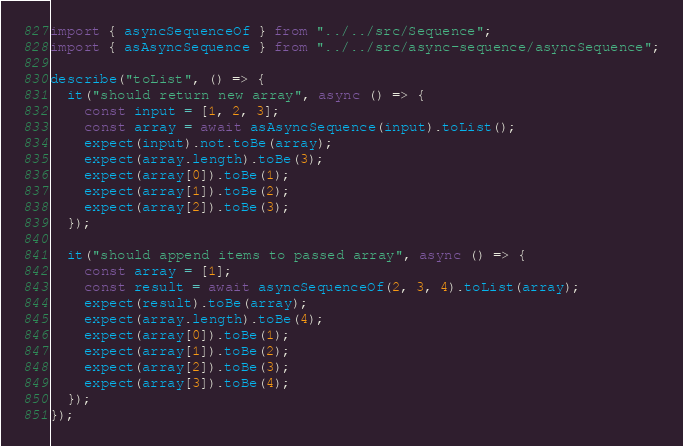<code> <loc_0><loc_0><loc_500><loc_500><_TypeScript_>import { asyncSequenceOf } from "../../src/Sequence";
import { asAsyncSequence } from "../../src/async-sequence/asyncSequence";

describe("toList", () => {
  it("should return new array", async () => {
    const input = [1, 2, 3];
    const array = await asAsyncSequence(input).toList();
    expect(input).not.toBe(array);
    expect(array.length).toBe(3);
    expect(array[0]).toBe(1);
    expect(array[1]).toBe(2);
    expect(array[2]).toBe(3);
  });

  it("should append items to passed array", async () => {
    const array = [1];
    const result = await asyncSequenceOf(2, 3, 4).toList(array);
    expect(result).toBe(array);
    expect(array.length).toBe(4);
    expect(array[0]).toBe(1);
    expect(array[1]).toBe(2);
    expect(array[2]).toBe(3);
    expect(array[3]).toBe(4);
  });
});
</code> 